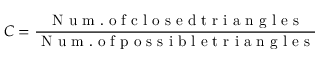Convert formula to latex. <formula><loc_0><loc_0><loc_500><loc_500>C = \frac { N u m . o f c l o s e d t r i a n g l e s } { N u m . o f p o s s i b l e t r i a n g l e s }</formula> 